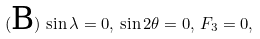<formula> <loc_0><loc_0><loc_500><loc_500>( \text {B} ) \, \sin \lambda = 0 , \, \sin 2 \theta = 0 , \, F _ { 3 } = 0 ,</formula> 